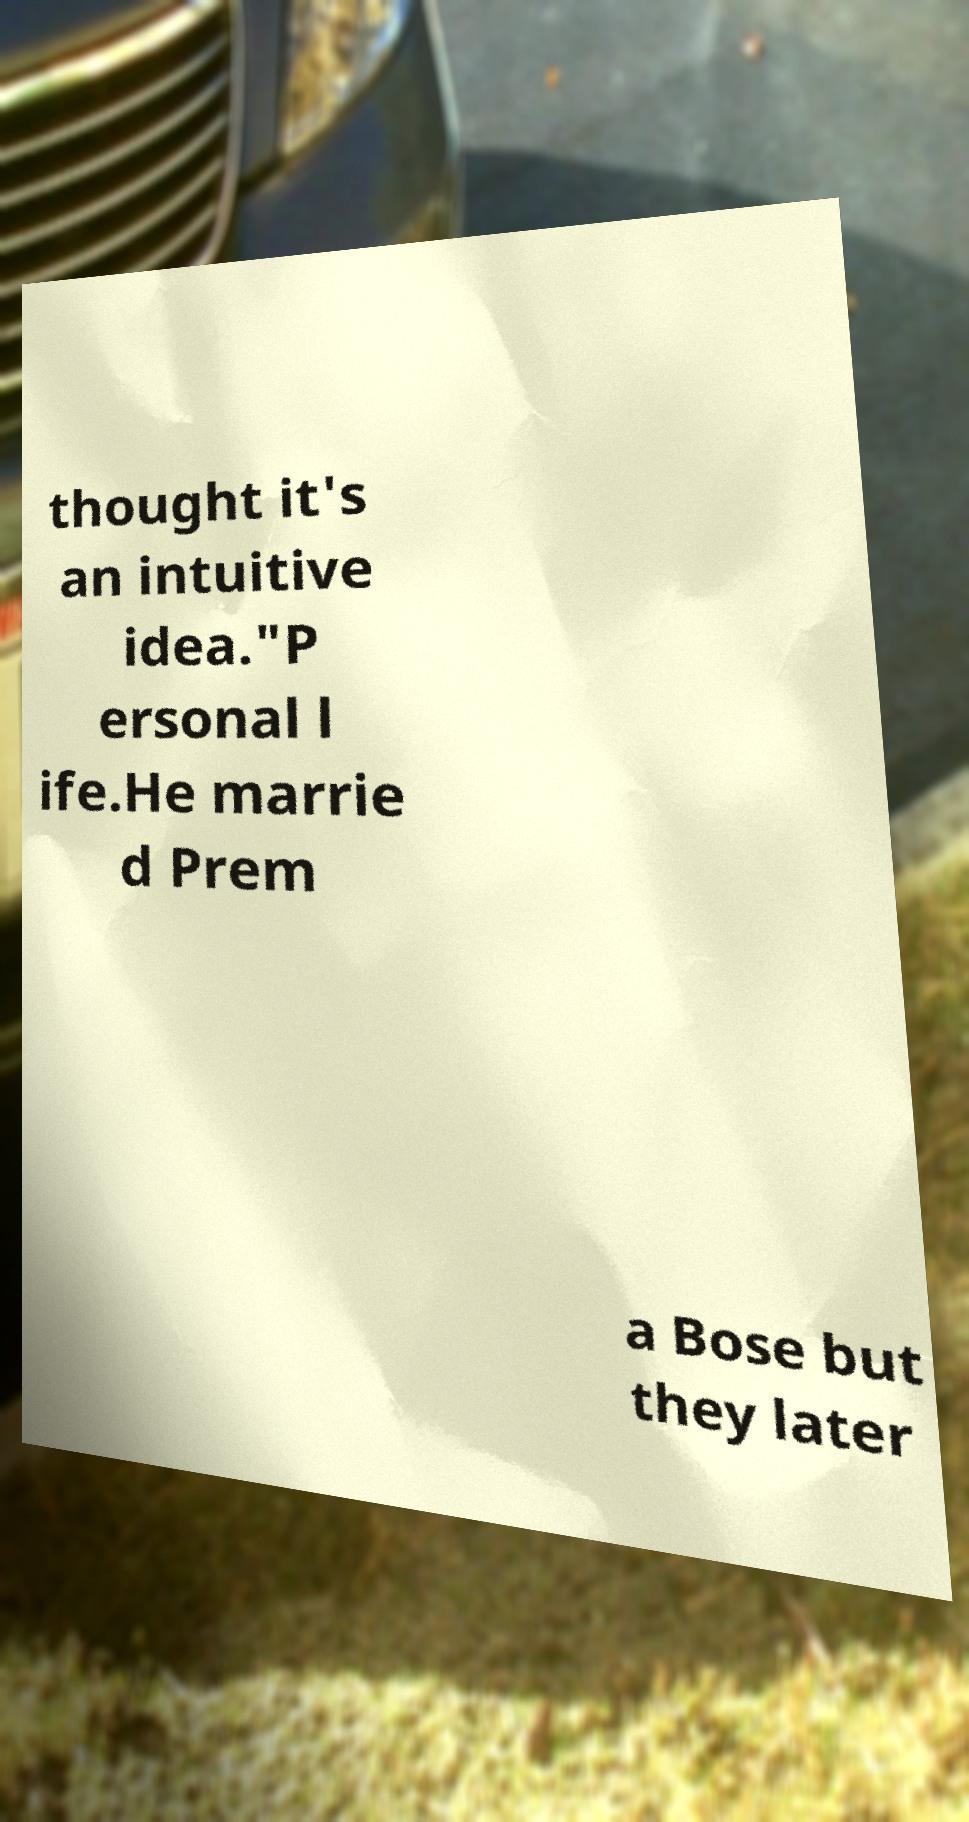Could you assist in decoding the text presented in this image and type it out clearly? thought it's an intuitive idea."P ersonal l ife.He marrie d Prem a Bose but they later 